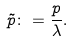<formula> <loc_0><loc_0><loc_500><loc_500>\tilde { p } \colon = \frac { p } { \lambda } .</formula> 